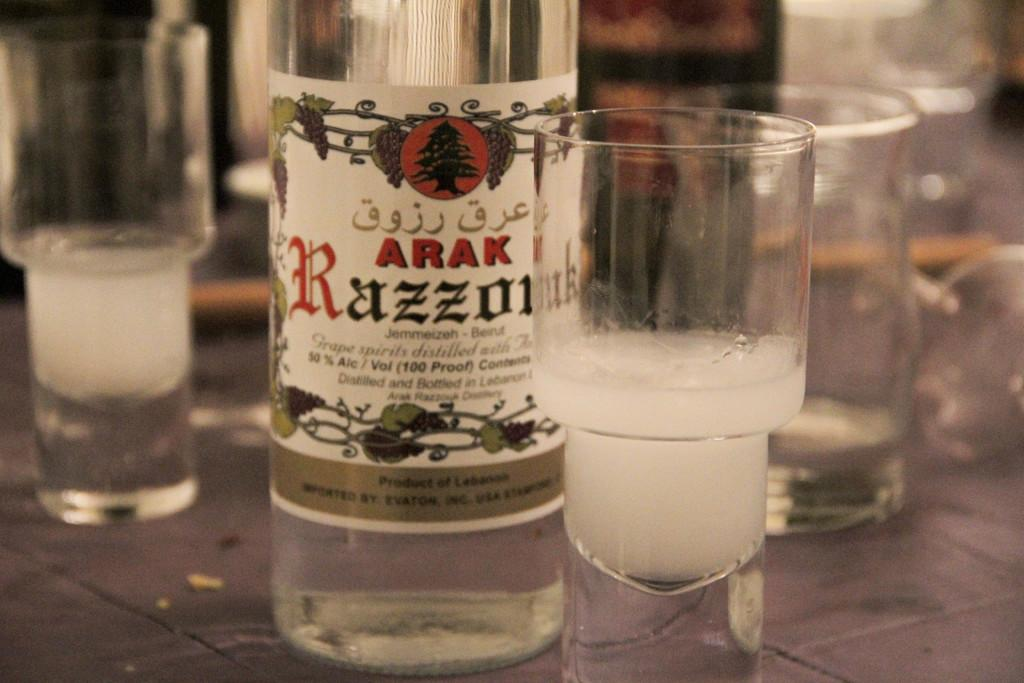<image>
Provide a brief description of the given image. A bottle of Arak 50% alcohol and some shot glasses beside it. 